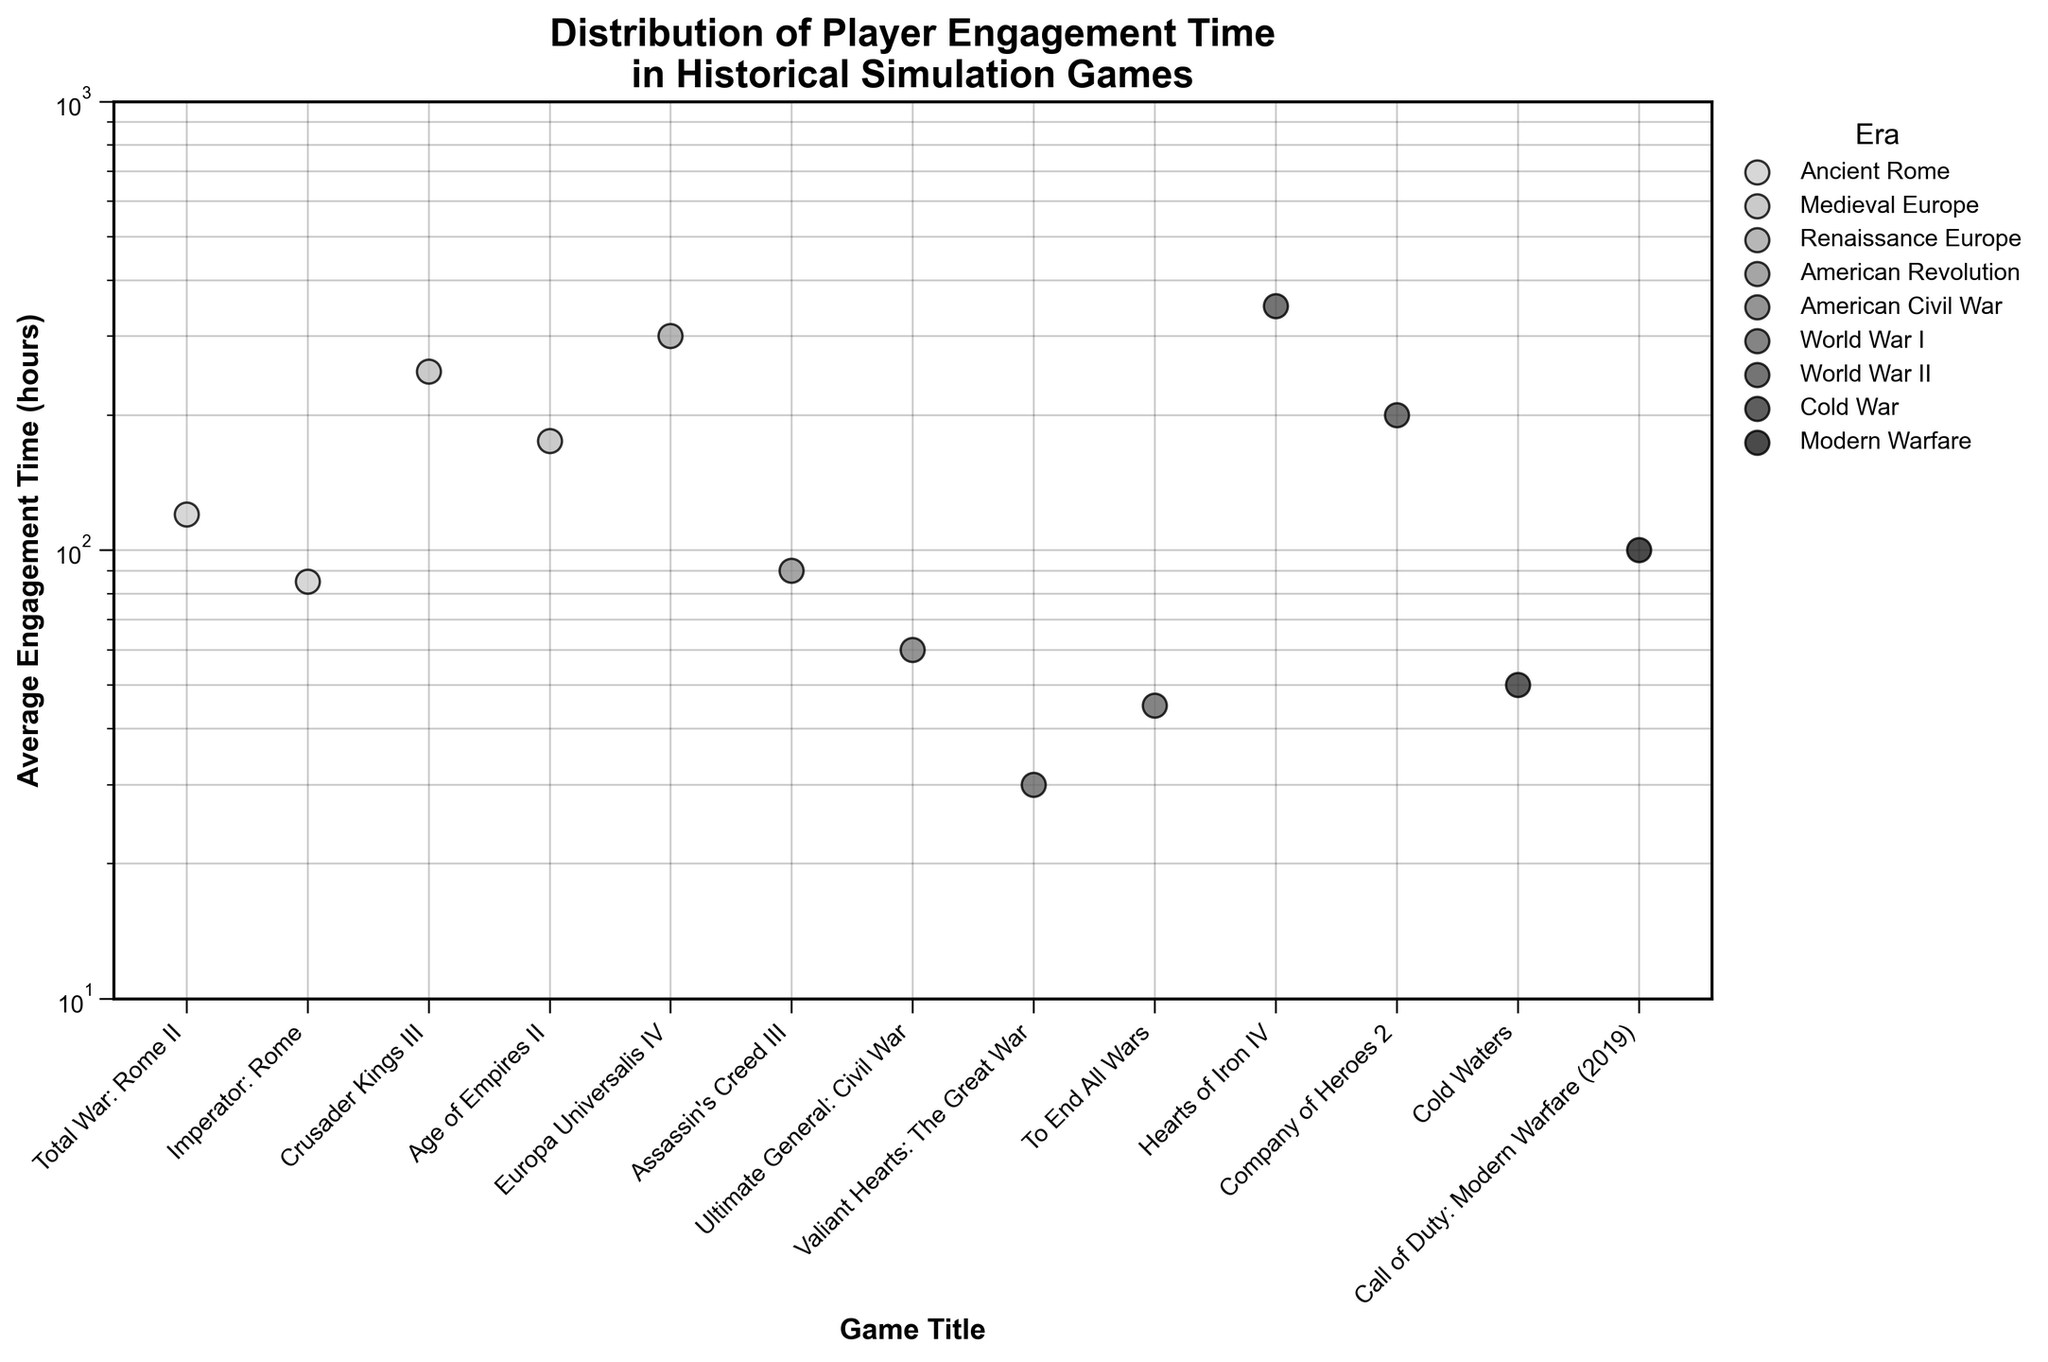What is the title of the figure? The title is located at the top of the figure and provides an overview of what the plot is about. It mentions the distribution of player engagement times in historical simulation games.
Answer: Distribution of Player Engagement Time in Historical Simulation Games What's the range of the y-axis in the plot? The y-axis is marked on the left side of the plot, indicating the range for the average engagement time in hours. Given that it is on a logarithmic scale, it shows a range from 10 to 1000 hours.
Answer: 10 to 1000 Which game has the highest average engagement time, and during which era does it belong? By observing the points on the scatter plot, the game at the highest position on the y-axis indicates the highest average engagement time. Hearts of Iron IV is the one with the highest value at 350 hours.
Answer: Hearts of Iron IV, World War II How many games are plotted from the Medieval Europe era? To answer this, look at the legend or count the data points corresponding to Medieval Europe. There are 2 games listed: Crusader Kings III and Age of Empires II.
Answer: 2 Which game has the lowest engagement time, and what is its value? By observing the data points on the scatter plot, the point at the lowest position on the y-axis represents the lowest engagement time. Valiant Hearts: The Great War has the lowest value at 30 hours.
Answer: Valiant Hearts: The Great War, 30 hours Compare the average engagement times for the games from World War I and State the game with the higher value. Looking at the points for World War I, observe To End All Wars and Valiant Hearts: The Great War. To End All Wars has 45 hours, which is higher than 30 hours for Valiant Hearts: The Great War.
Answer: To End All Wars What is the average engagement time for games belonging to the World War II era? Add the average engagement times for Hearts of Iron IV (350) and Company of Heroes 2 (200), then divide by the number of games (2). \( \frac{350 + 200}{2} = 275 \)
Answer: 275 Which era has the most diversity in player engagement times, and how can you tell? Look at the range of y-values for different eras. World War II shows large variance between 200 (Company of Heroes 2) and 350 (Hearts of Iron IV).
Answer: World War II Are there any games from the Modern Warfare era on the plot? If so, what is their engagement time? By finding the point corresponding to Modern Warfare in the scatter plot, Call of Duty: Modern Warfare (2019) is located with an engagement time of 100 hours.
Answer: Yes, 100 hours 